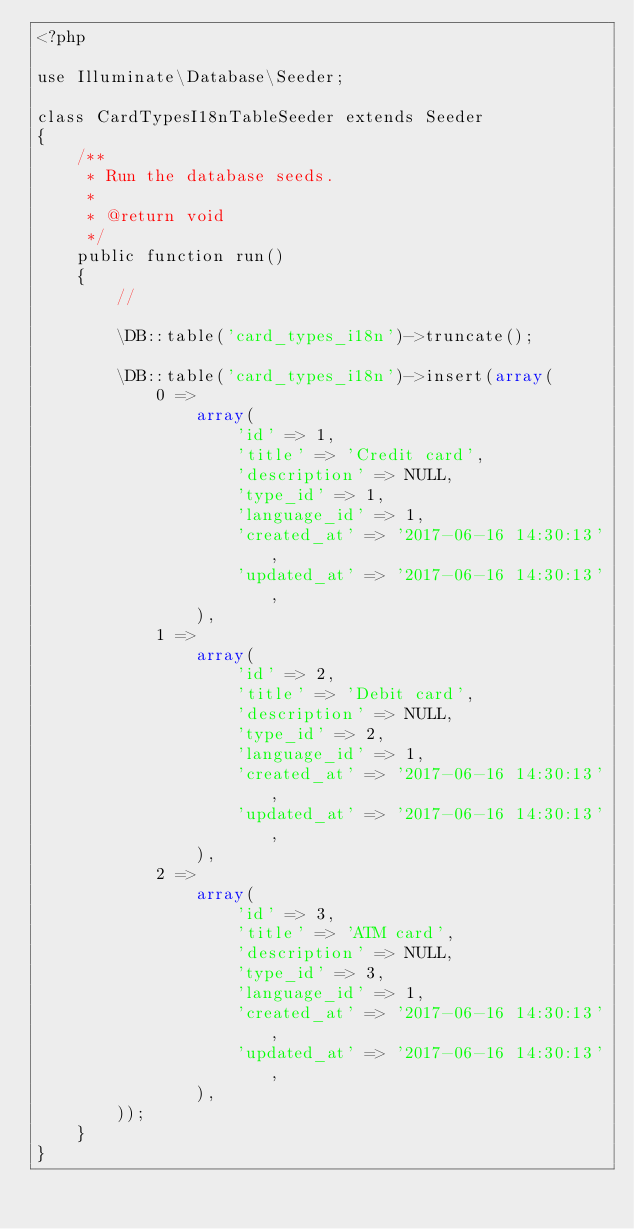<code> <loc_0><loc_0><loc_500><loc_500><_PHP_><?php

use Illuminate\Database\Seeder;

class CardTypesI18nTableSeeder extends Seeder
{
    /**
     * Run the database seeds.
     *
     * @return void
     */
    public function run()
    {
        //

        \DB::table('card_types_i18n')->truncate();

        \DB::table('card_types_i18n')->insert(array(
            0 =>
                array(
                    'id' => 1,
                    'title' => 'Credit card',
                    'description' => NULL,
                    'type_id' => 1,
                    'language_id' => 1,
                    'created_at' => '2017-06-16 14:30:13',
                    'updated_at' => '2017-06-16 14:30:13',
                ),
            1 =>
                array(
                    'id' => 2,
                    'title' => 'Debit card',
                    'description' => NULL,
                    'type_id' => 2,
                    'language_id' => 1,
                    'created_at' => '2017-06-16 14:30:13',
                    'updated_at' => '2017-06-16 14:30:13',
                ),
            2 =>
                array(
                    'id' => 3,
                    'title' => 'ATM card',
                    'description' => NULL,
                    'type_id' => 3,
                    'language_id' => 1,
                    'created_at' => '2017-06-16 14:30:13',
                    'updated_at' => '2017-06-16 14:30:13',
                ),
        ));
    }
}
</code> 